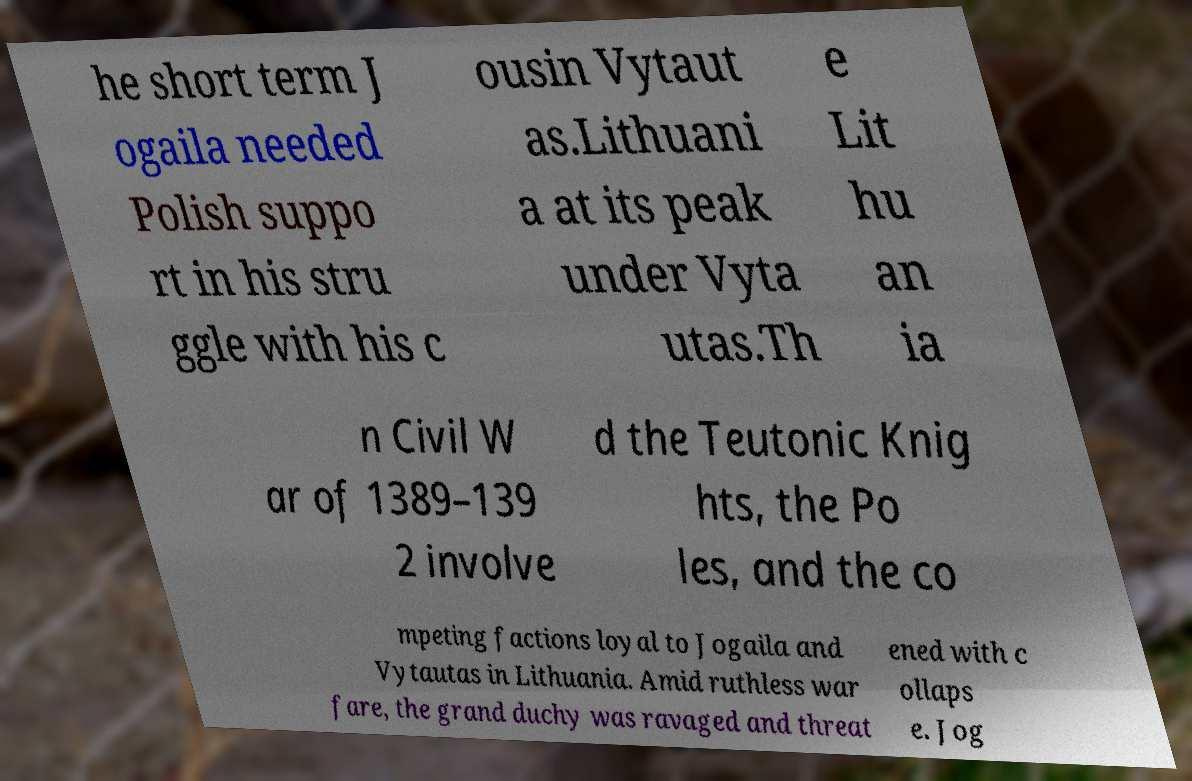What messages or text are displayed in this image? I need them in a readable, typed format. he short term J ogaila needed Polish suppo rt in his stru ggle with his c ousin Vytaut as.Lithuani a at its peak under Vyta utas.Th e Lit hu an ia n Civil W ar of 1389–139 2 involve d the Teutonic Knig hts, the Po les, and the co mpeting factions loyal to Jogaila and Vytautas in Lithuania. Amid ruthless war fare, the grand duchy was ravaged and threat ened with c ollaps e. Jog 